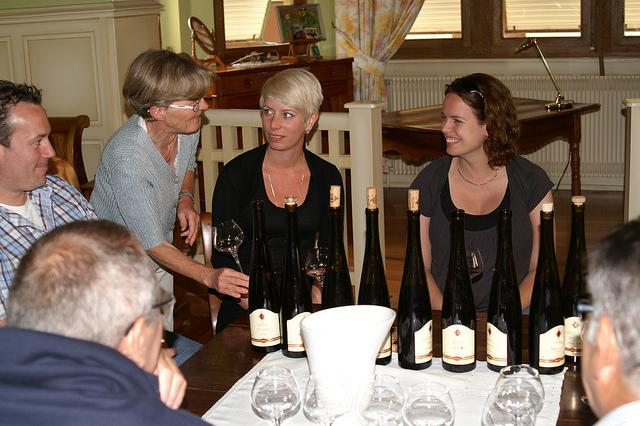What is in the bottle all the way to the right that is near the brunette woman? wine 